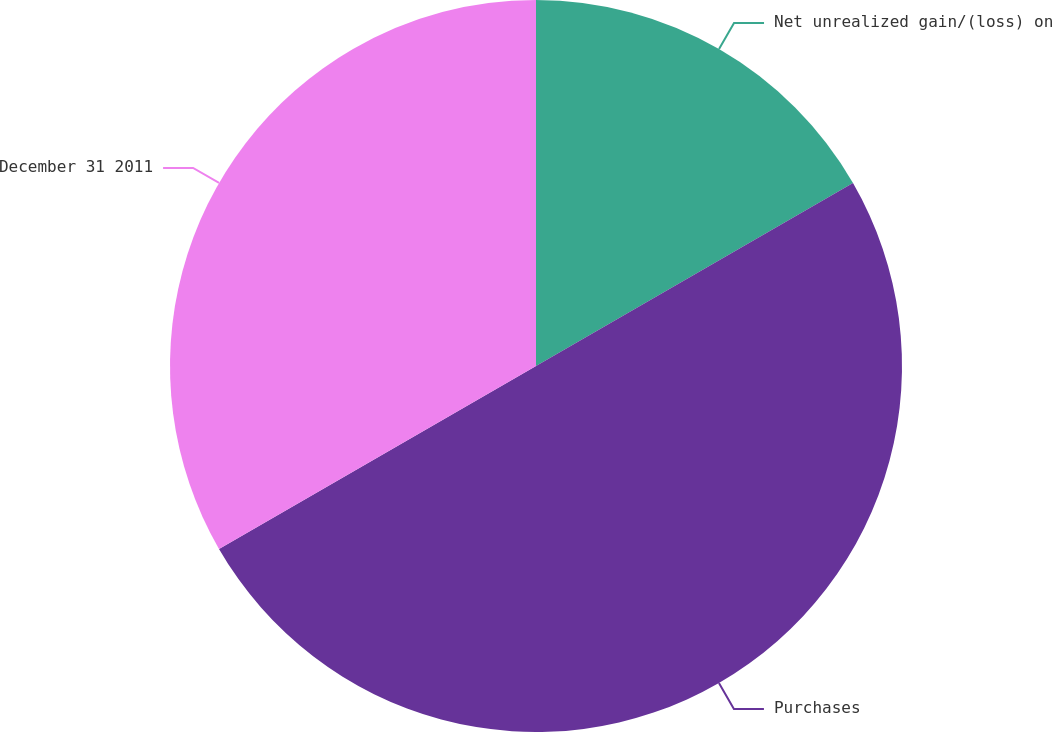Convert chart to OTSL. <chart><loc_0><loc_0><loc_500><loc_500><pie_chart><fcel>Net unrealized gain/(loss) on<fcel>Purchases<fcel>December 31 2011<nl><fcel>16.67%<fcel>50.0%<fcel>33.33%<nl></chart> 